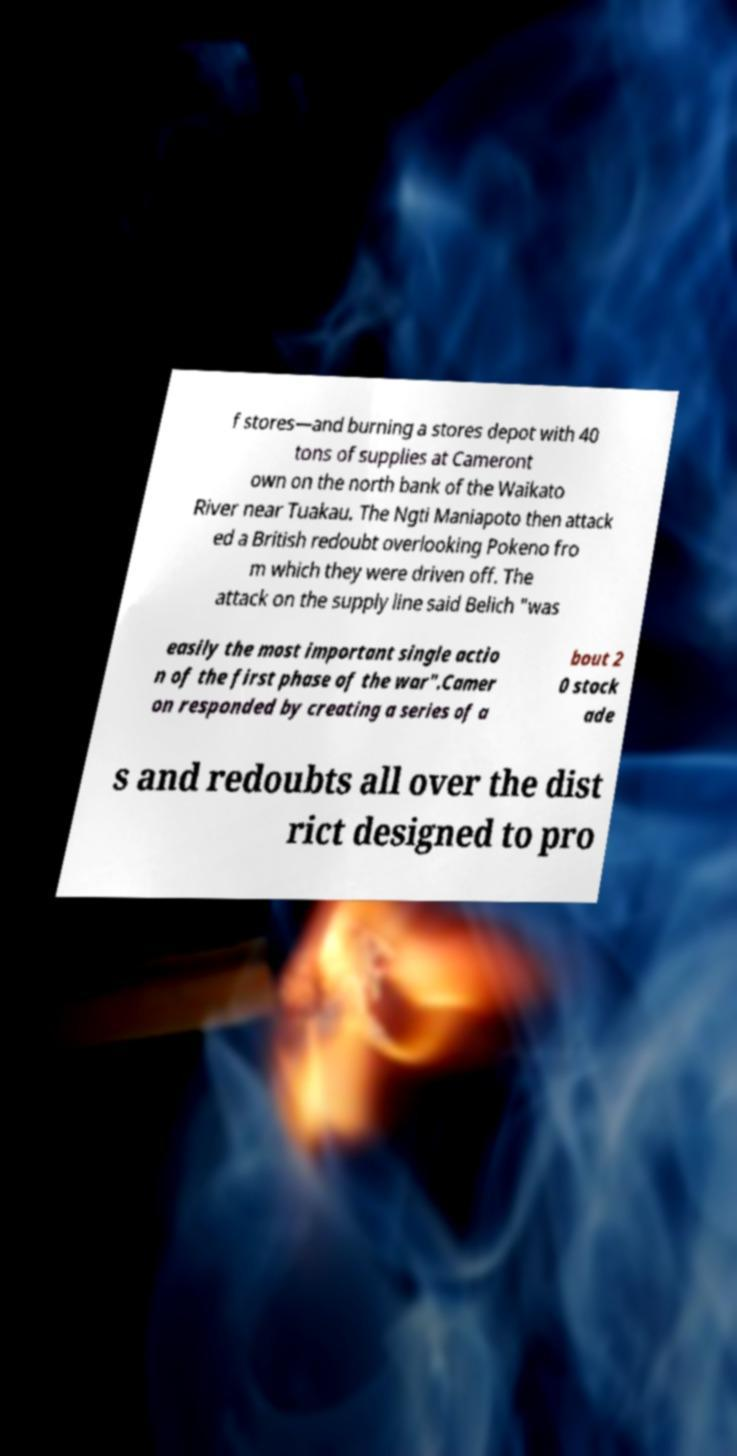Please identify and transcribe the text found in this image. f stores—and burning a stores depot with 40 tons of supplies at Cameront own on the north bank of the Waikato River near Tuakau. The Ngti Maniapoto then attack ed a British redoubt overlooking Pokeno fro m which they were driven off. The attack on the supply line said Belich "was easily the most important single actio n of the first phase of the war".Camer on responded by creating a series of a bout 2 0 stock ade s and redoubts all over the dist rict designed to pro 